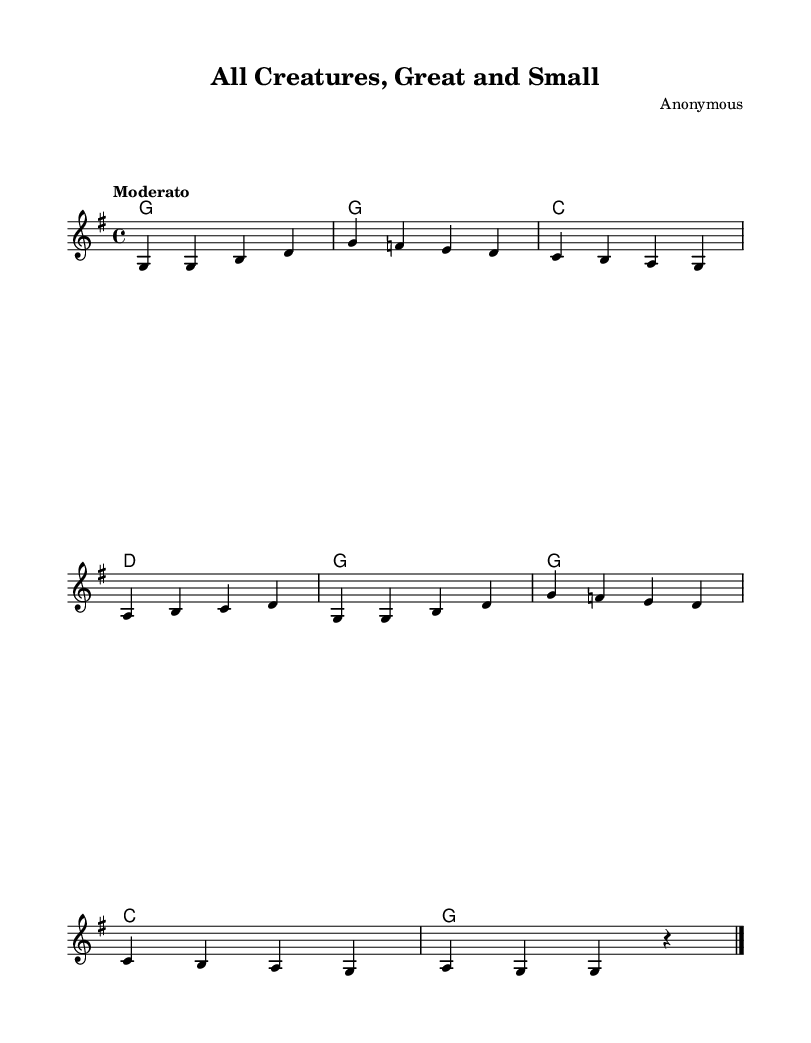What is the key signature of this music? The key signature is G major, which has one sharp (F#). This can be determined by looking at the key signature shown at the beginning of the staff.
Answer: G major What is the time signature of this piece? The time signature is 4/4, which means there are four beats in each measure, and the quarter note gets one beat. This is visible in the notation at the beginning of the piece.
Answer: 4/4 What is the tempo marking for this hymn? The tempo marking is "Moderato," indicating a moderate pace for the performance. This information is presented at the beginning of the score.
Answer: Moderato How many measures are there in the melody? There are eight measures in the melody part, which can be counted by observing the visual divisions in the score where the bar lines appear.
Answer: 8 What is the first lyric line of the hymn? The first lyric line is "All creatures great and small," which can be found directly under the melody staff.
Answer: All creatures great and small What do the lyrics express about God's love? The lyrics describe that God loves all creatures, from the smallest to the largest, emphasizing inclusivity. This thematic content can be inferred from the text itself as seen in the score.
Answer: God's love for all What is the performance instrument indicated in the score? The performance instrument indicated is "acoustic grand," which is specified in the melody staff. This tells us what type of instrument the music is arranged for.
Answer: Acoustic grand 